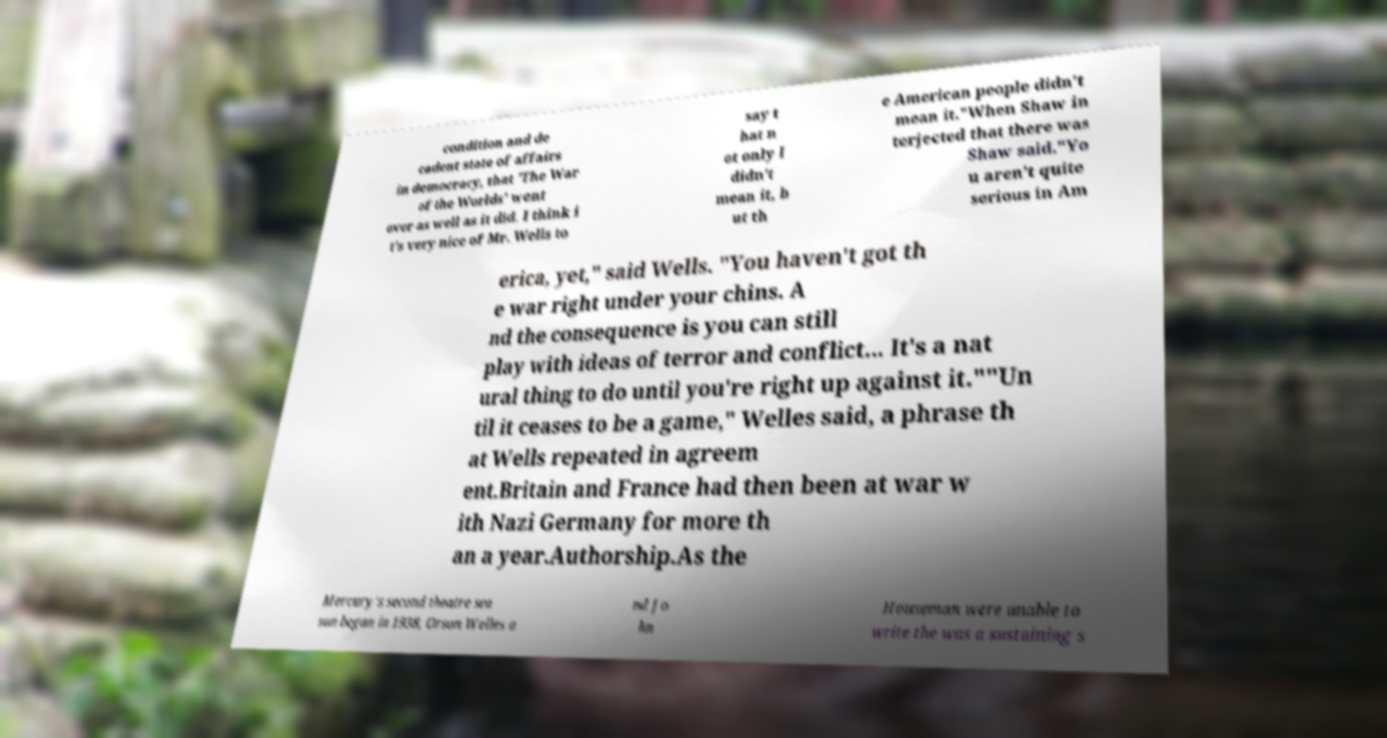Could you extract and type out the text from this image? condition and de cadent state of affairs in democracy, that 'The War of the Worlds' went over as well as it did. I think i t's very nice of Mr. Wells to say t hat n ot only I didn't mean it, b ut th e American people didn't mean it."When Shaw in terjected that there was Shaw said."Yo u aren't quite serious in Am erica, yet," said Wells. "You haven't got th e war right under your chins. A nd the consequence is you can still play with ideas of terror and conflict... It's a nat ural thing to do until you're right up against it.""Un til it ceases to be a game," Welles said, a phrase th at Wells repeated in agreem ent.Britain and France had then been at war w ith Nazi Germany for more th an a year.Authorship.As the Mercury's second theatre sea son began in 1938, Orson Welles a nd Jo hn Houseman were unable to write the was a sustaining s 